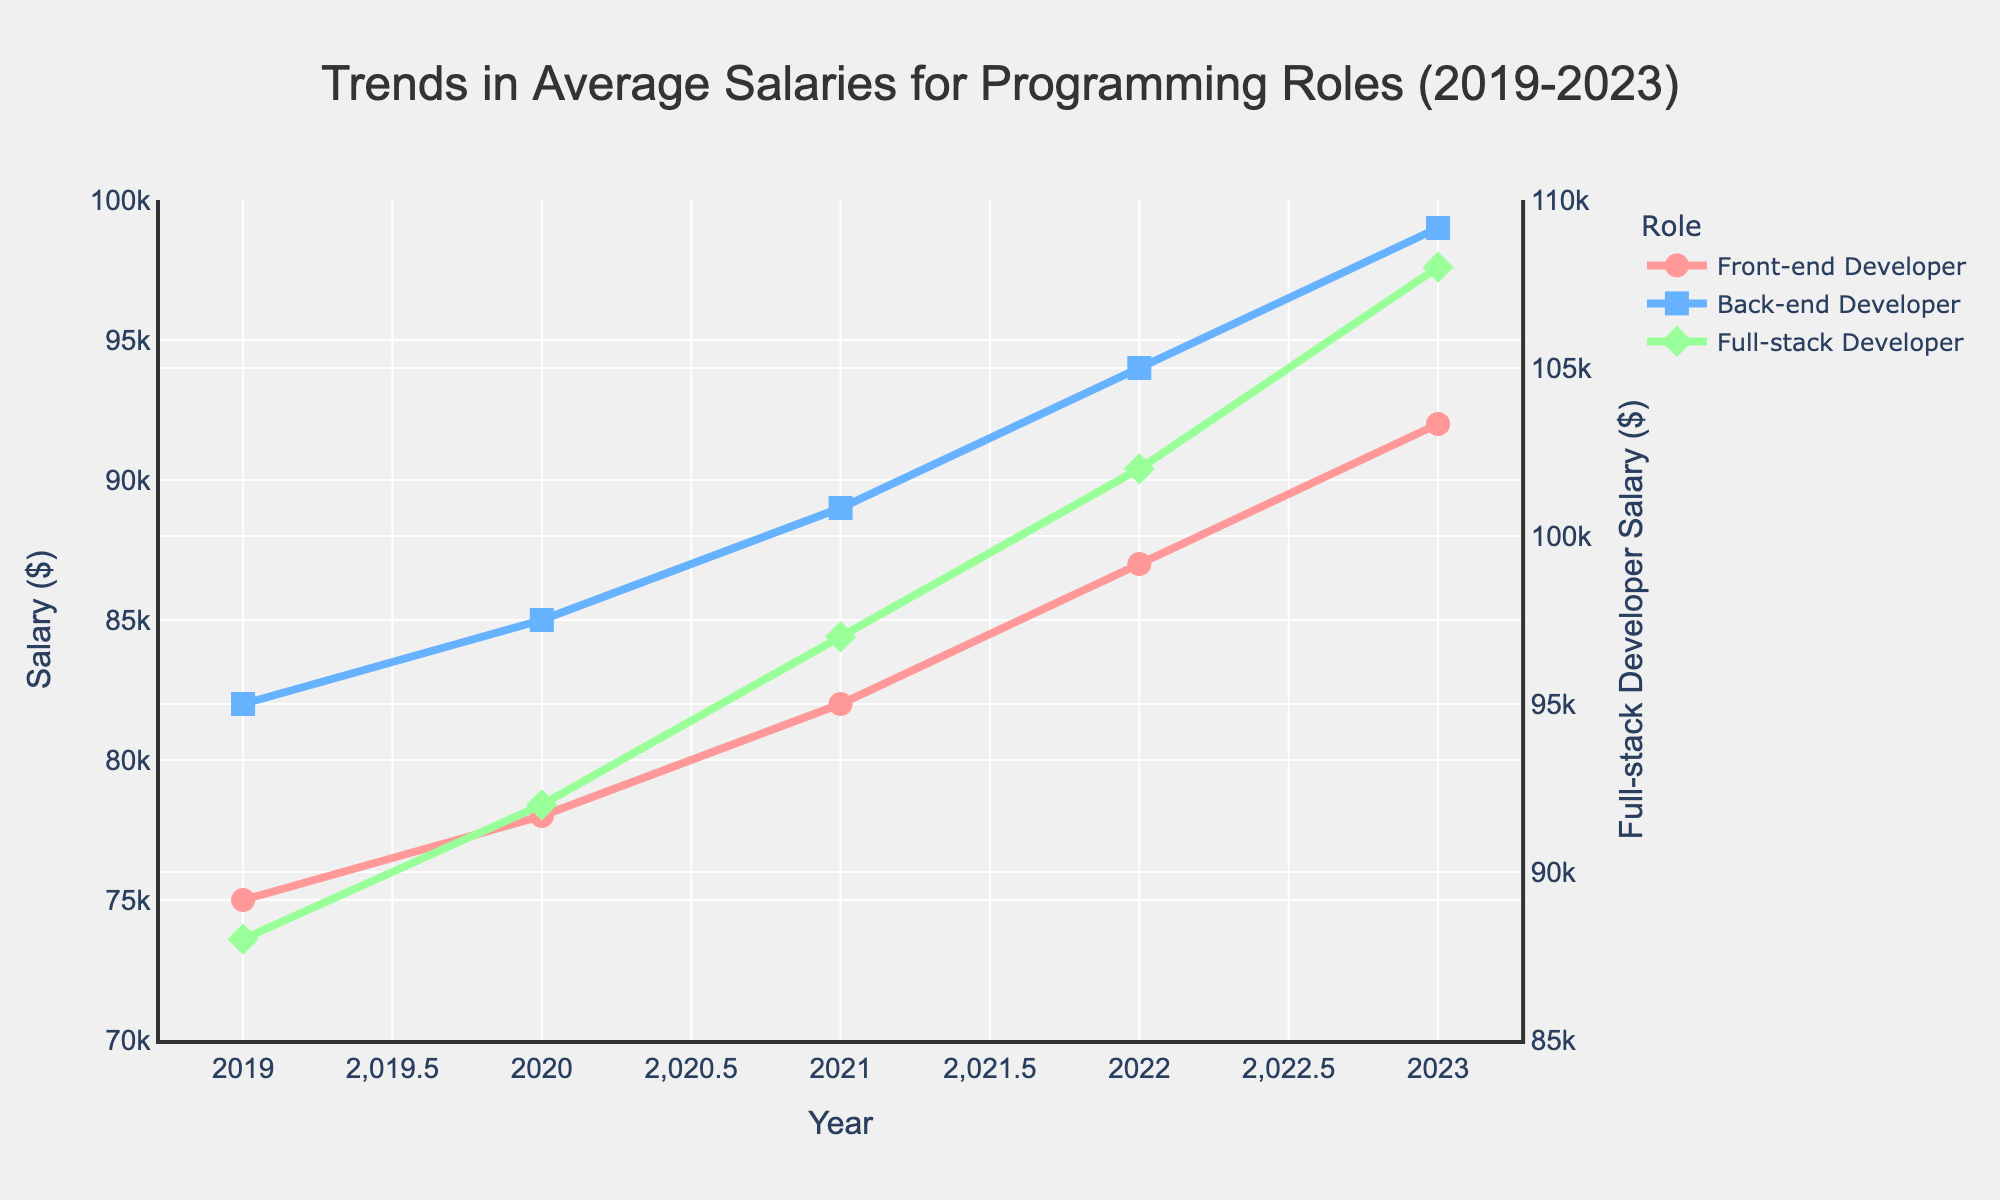What is the salary of a Front-end Developer in 2022? The figure shows the salary trends, and looking at the data point for the year 2022, the salary for a Front-end Developer is indicated.
Answer: 87000 What are the trends in the salaries of Full-stack Developers from 2019 to 2023? By observing the green line representing the Full-stack Developer, the salary increases each year from 2019 to 2023. Starting from 88,000 in 2019 to 108,000 in 2023.
Answer: Increasing trend from 88,000 in 2019 to 108,000 in 2023 How does the salary growth of Back-end Developers compare to Front-end Developers from 2019 to 2023? By comparing the trajectories of the blue line (Back-end Developer) and the red line (Front-end Developer), both lines show a consistent increase, but the difference between Back-end and Front-end salaries remains roughly the same over the years.
Answer: Both show consistent growth; the growth gap remains similar Which year shows the highest increase in salary for Full-stack Developers? By looking at the green line and the slope between the points, the largest increase is seen from 2021 to 2022.
Answer: 2022 In which year were the salaries of Back-end and Full-stack Developers closest to each other? By comparing the points and distances between the blue (Back-end) and green lines (Full-stack) across the years, the salaries were closest in 2019.
Answer: 2019 What is the difference in salaries between Front-end and Back-end Developers in 2020? By checking the values for 2020, the salary for Front-end Developers is 78,000 and for Back-end Developers is 85,000. The difference is 85,000 - 78,000.
Answer: 7000 How do the visual styles of the Front-end, Back-end, and Full-stack Developer salary lines differ? Observing the figure, the red line represents Front-end Developers with circular markers, blue represents Back-end Developers with square markers, and green represents Full-stack Developers with diamond markers. Each line has a distinct color and marker shape.
Answer: Red circles for Front-end, Blue squares for Back-end, Green diamonds for Full-stack What is the average salary for Front-end Developers across all these years? Summing the salaries for Front-end Developers for each year (75000, 78000, 82000, 87000, 92000) and dividing by 5 to find the average.
Answer: 82800 How much did Full-stack Developers' salaries increase from the lowest to the highest year? The lowest salary for Full-stack Developers is 88,000 in 2019, and the highest is 108,000 in 2023. The increase is 108,000 - 88,000.
Answer: 20000 